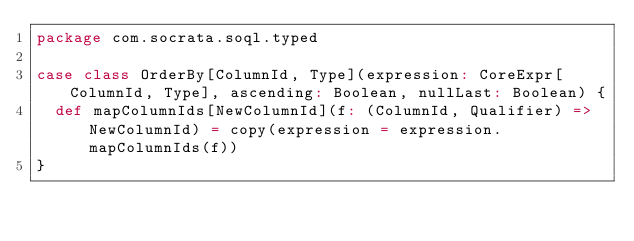<code> <loc_0><loc_0><loc_500><loc_500><_Scala_>package com.socrata.soql.typed

case class OrderBy[ColumnId, Type](expression: CoreExpr[ColumnId, Type], ascending: Boolean, nullLast: Boolean) {
  def mapColumnIds[NewColumnId](f: (ColumnId, Qualifier) => NewColumnId) = copy(expression = expression.mapColumnIds(f))
}
</code> 